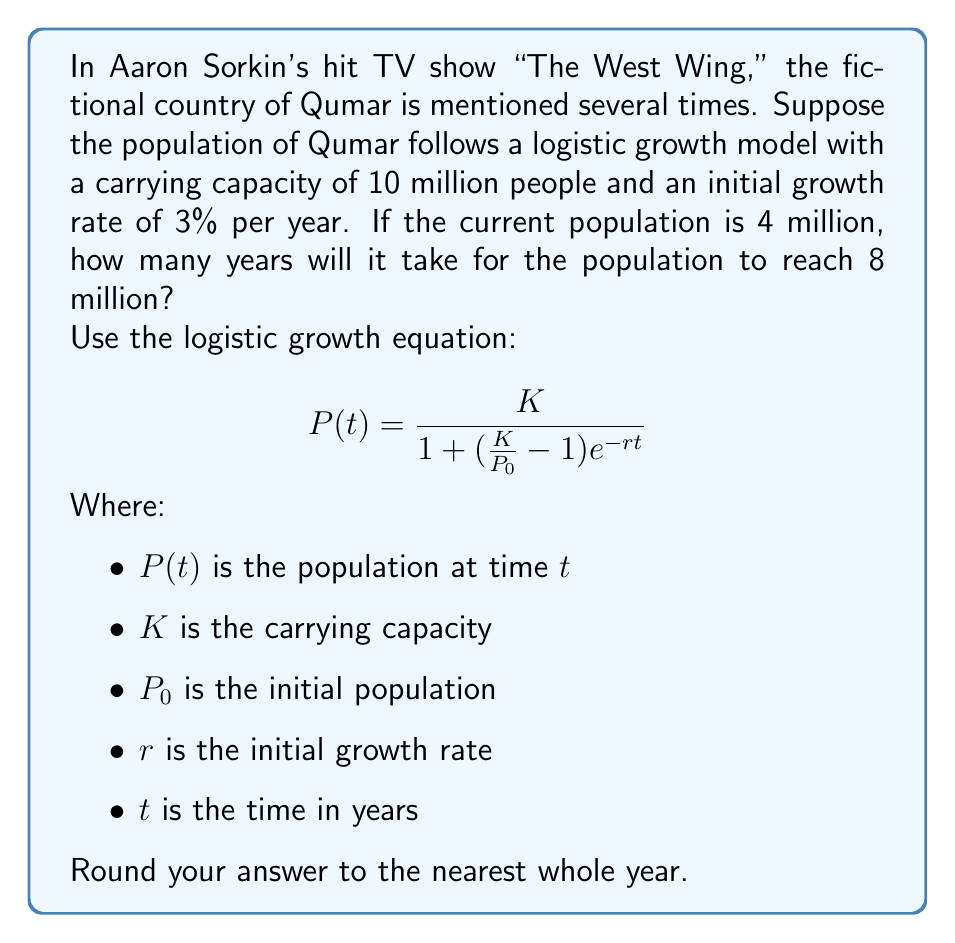Show me your answer to this math problem. To solve this problem, we'll use the logistic growth equation and the given information:

$K = 10$ million (carrying capacity)
$P_0 = 4$ million (initial population)
$r = 0.03$ (3% growth rate)
$P(t) = 8$ million (target population)

Let's substitute these values into the equation and solve for $t$:

$$8 = \frac{10}{1 + (\frac{10}{4} - 1)e^{-0.03t}}$$

Now, let's solve this equation step by step:

1) First, simplify the fraction inside the parentheses:
   $$8 = \frac{10}{1 + (2.5 - 1)e^{-0.03t}} = \frac{10}{1 + 1.5e^{-0.03t}}$$

2) Multiply both sides by the denominator:
   $$8(1 + 1.5e^{-0.03t}) = 10$$

3) Expand the left side:
   $$8 + 12e^{-0.03t} = 10$$

4) Subtract 8 from both sides:
   $$12e^{-0.03t} = 2$$

5) Divide both sides by 12:
   $$e^{-0.03t} = \frac{1}{6}$$

6) Take the natural log of both sides:
   $$-0.03t = \ln(\frac{1}{6})$$

7) Divide both sides by -0.03:
   $$t = \frac{\ln(\frac{1}{6})}{-0.03} = \frac{\ln(6)}{0.03}$$

8) Calculate the result:
   $$t \approx 59.86 \text{ years}$$

Rounding to the nearest whole year, we get 60 years.
Answer: 60 years 